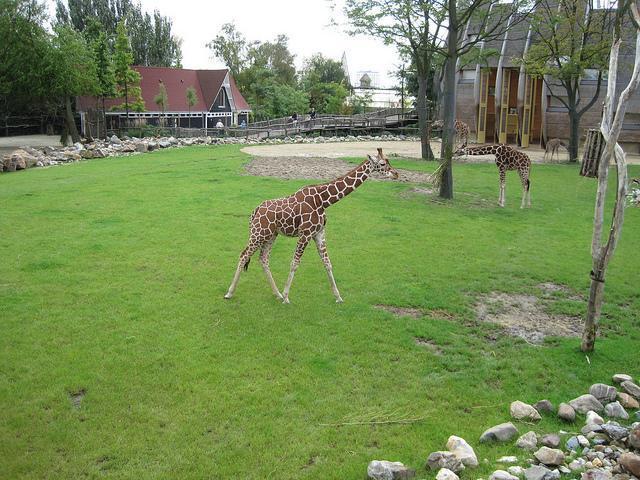How many trucks are crushing on the street?
Give a very brief answer. 0. 